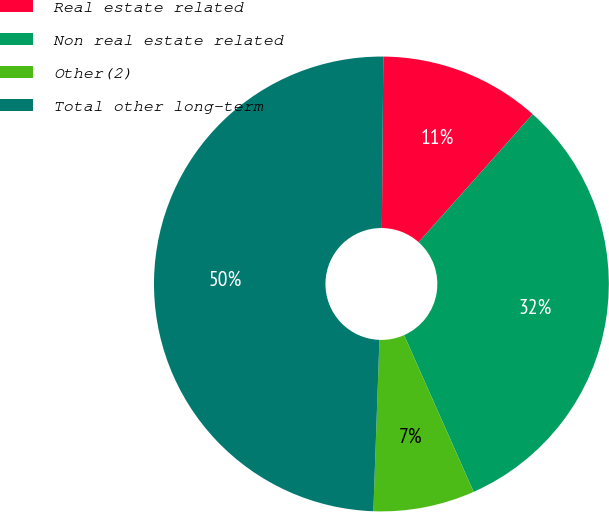<chart> <loc_0><loc_0><loc_500><loc_500><pie_chart><fcel>Real estate related<fcel>Non real estate related<fcel>Other(2)<fcel>Total other long-term<nl><fcel>11.45%<fcel>31.77%<fcel>7.21%<fcel>49.57%<nl></chart> 